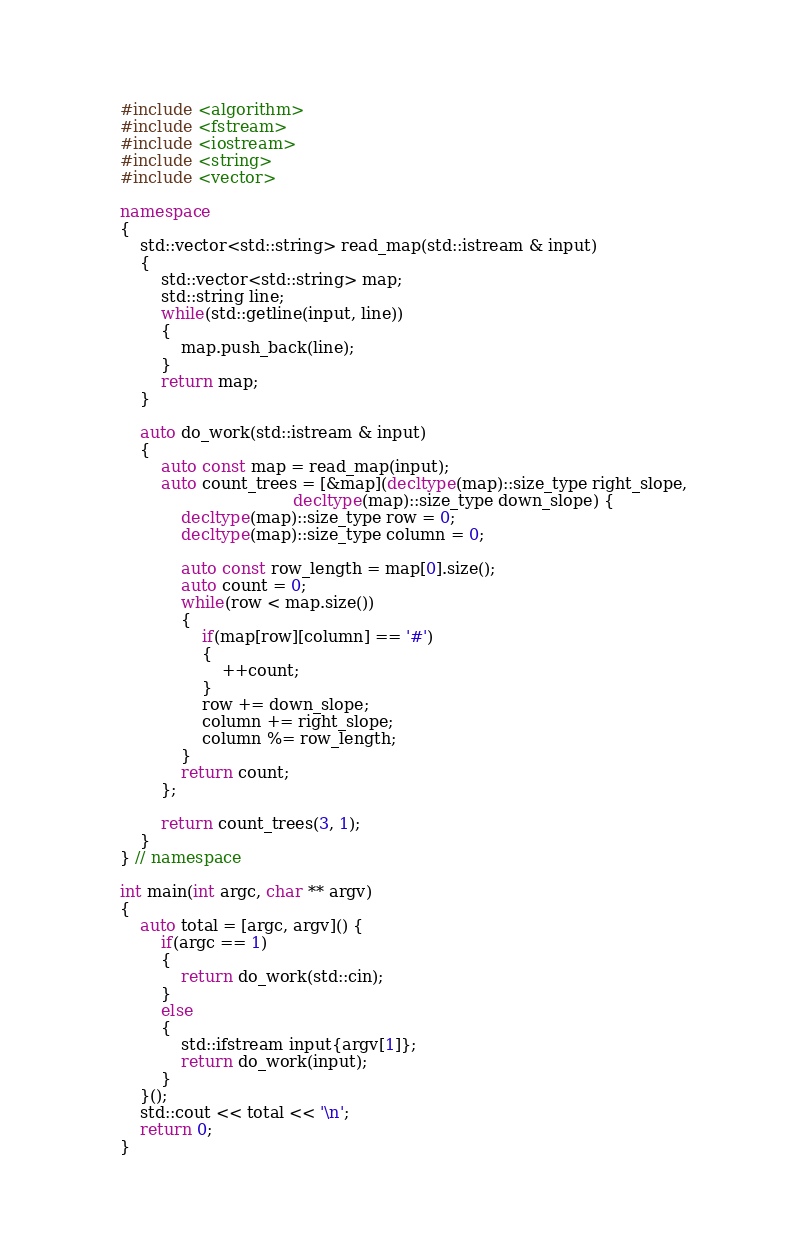Convert code to text. <code><loc_0><loc_0><loc_500><loc_500><_C++_>#include <algorithm>
#include <fstream>
#include <iostream>
#include <string>
#include <vector>

namespace
{
    std::vector<std::string> read_map(std::istream & input)
    {
        std::vector<std::string> map;
        std::string line;
        while(std::getline(input, line))
        {
            map.push_back(line);
        }
        return map;
    }

    auto do_work(std::istream & input)
    {
        auto const map = read_map(input);
        auto count_trees = [&map](decltype(map)::size_type right_slope,
                                  decltype(map)::size_type down_slope) {
            decltype(map)::size_type row = 0;
            decltype(map)::size_type column = 0;

            auto const row_length = map[0].size();
            auto count = 0;
            while(row < map.size())
            {
                if(map[row][column] == '#')
                {
                    ++count;
                }
                row += down_slope;
                column += right_slope;
                column %= row_length;
            }
            return count;
        };

        return count_trees(3, 1);
    }
} // namespace

int main(int argc, char ** argv)
{
    auto total = [argc, argv]() {
        if(argc == 1)
        {
            return do_work(std::cin);
        }
        else
        {
            std::ifstream input{argv[1]};
            return do_work(input);
        }
    }();
    std::cout << total << '\n';
    return 0;
}
</code> 